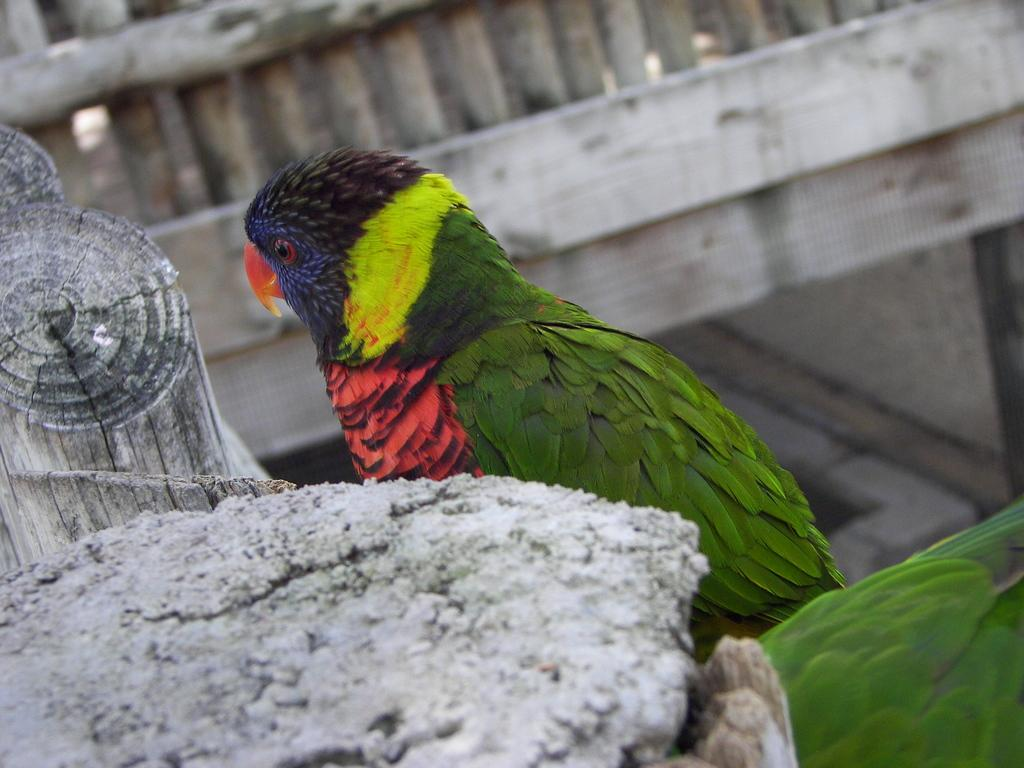What type of animals can be seen in the image? Birds can be seen in the image. What material is visible in the image? Wood is visible in the image. What is the surface on which the birds are standing? The ground is visible in the image. What architectural feature can be seen in the background of the image? There is a fence in the background of the image. What type of arch can be seen in the image? There is no arch present in the image. 